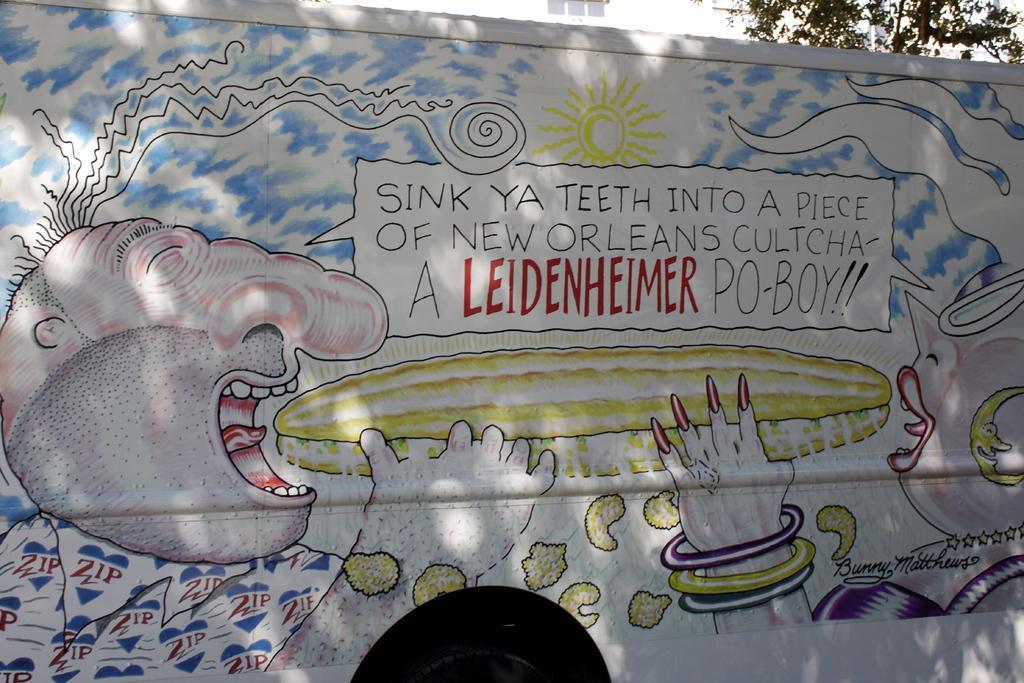Please provide a concise description of this image. Here is a vehicle where we can see a painting on it there are two people one on the left and other on the right in between their mouths there is a sand -witch where both of them are holding it and above the sand-witch there is a text written and above the text there is also a sun and the remaining part of the bus is painted with blue color. 